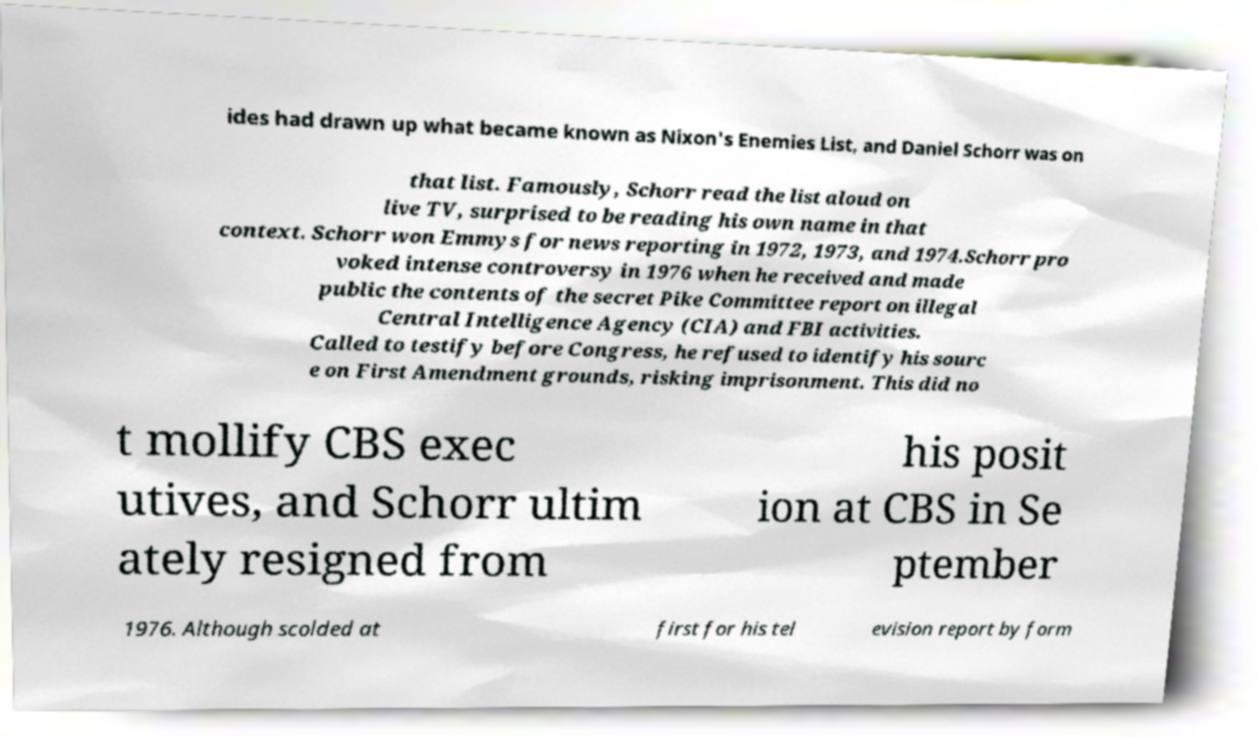Can you read and provide the text displayed in the image?This photo seems to have some interesting text. Can you extract and type it out for me? ides had drawn up what became known as Nixon's Enemies List, and Daniel Schorr was on that list. Famously, Schorr read the list aloud on live TV, surprised to be reading his own name in that context. Schorr won Emmys for news reporting in 1972, 1973, and 1974.Schorr pro voked intense controversy in 1976 when he received and made public the contents of the secret Pike Committee report on illegal Central Intelligence Agency (CIA) and FBI activities. Called to testify before Congress, he refused to identify his sourc e on First Amendment grounds, risking imprisonment. This did no t mollify CBS exec utives, and Schorr ultim ately resigned from his posit ion at CBS in Se ptember 1976. Although scolded at first for his tel evision report by form 